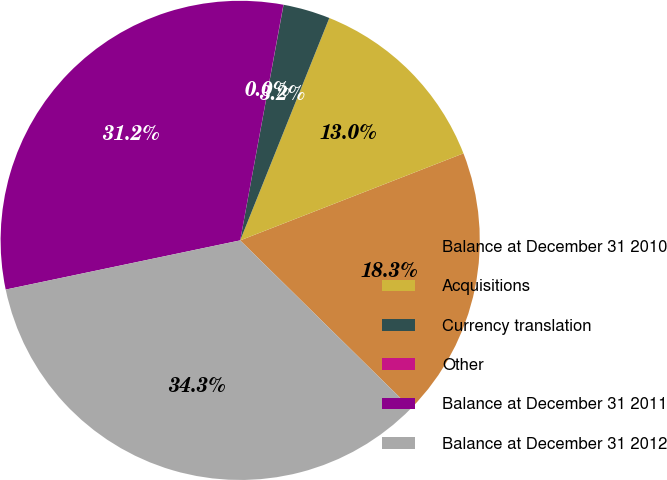Convert chart. <chart><loc_0><loc_0><loc_500><loc_500><pie_chart><fcel>Balance at December 31 2010<fcel>Acquisitions<fcel>Currency translation<fcel>Other<fcel>Balance at December 31 2011<fcel>Balance at December 31 2012<nl><fcel>18.29%<fcel>13.02%<fcel>3.17%<fcel>0.01%<fcel>31.18%<fcel>34.34%<nl></chart> 